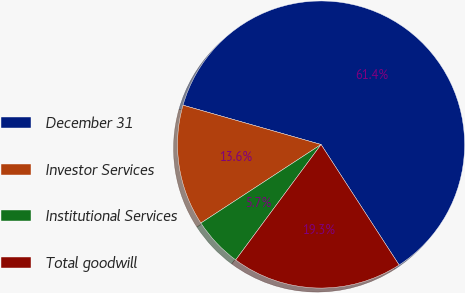Convert chart to OTSL. <chart><loc_0><loc_0><loc_500><loc_500><pie_chart><fcel>December 31<fcel>Investor Services<fcel>Institutional Services<fcel>Total goodwill<nl><fcel>61.43%<fcel>13.63%<fcel>5.65%<fcel>19.28%<nl></chart> 